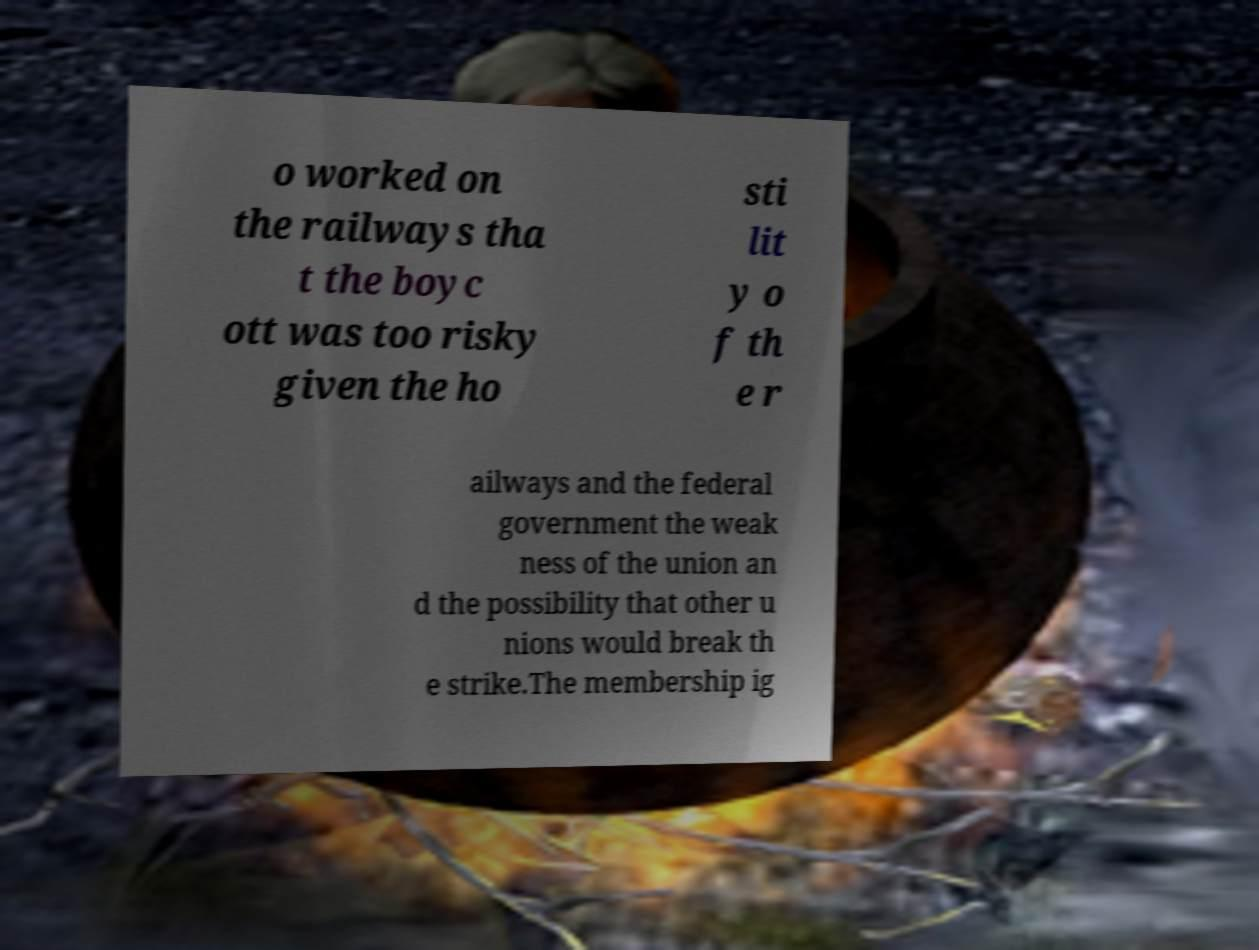Could you assist in decoding the text presented in this image and type it out clearly? o worked on the railways tha t the boyc ott was too risky given the ho sti lit y o f th e r ailways and the federal government the weak ness of the union an d the possibility that other u nions would break th e strike.The membership ig 